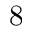Convert formula to latex. <formula><loc_0><loc_0><loc_500><loc_500>8</formula> 